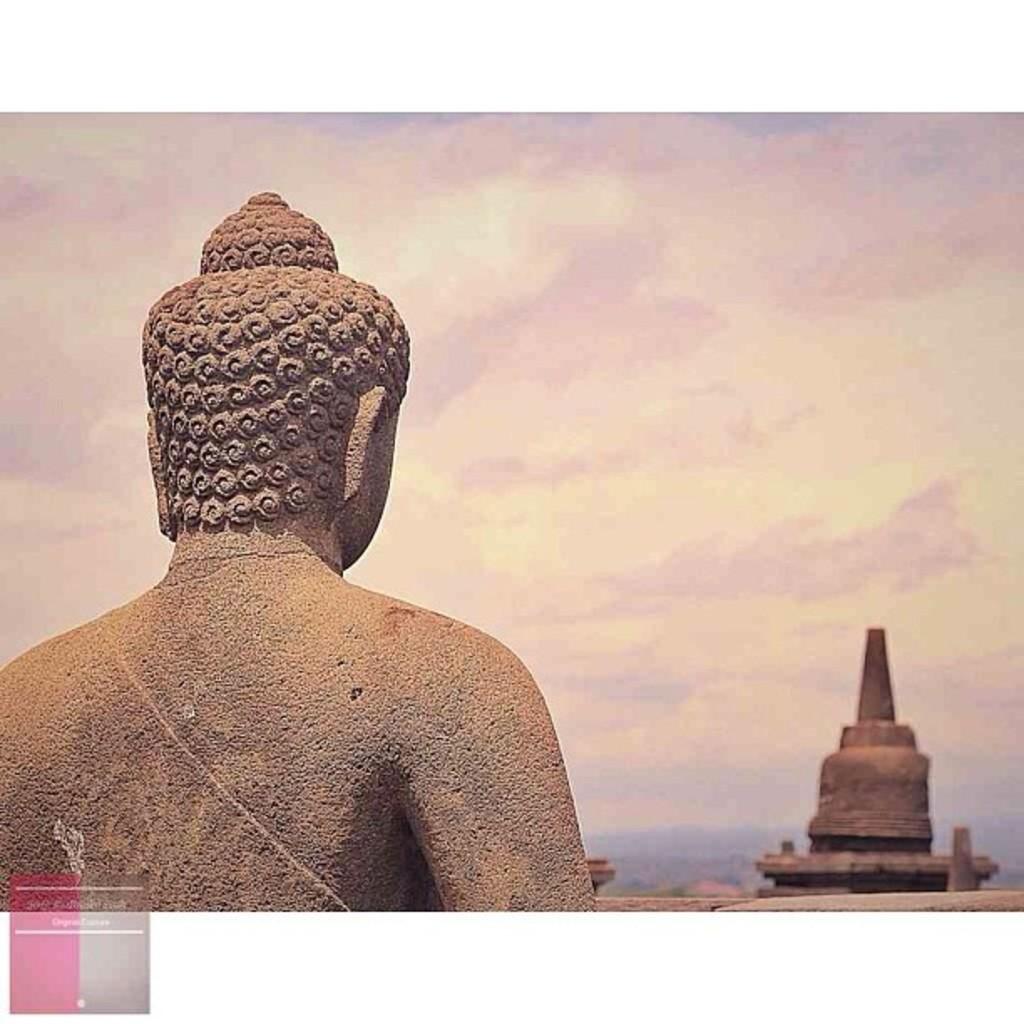What is the main subject in the image? There is a statue in the image. What can be seen in the background of the image? The sky is visible in the background of the image. What is located on the right side of the image? There is an object on the right side of the image. Where is the logo placed in the image? The logo is in the left side bottom corner of the image. What type of yarn is the statue holding in the image? The statue is not holding any yarn in the image. Can you tell me how many brothers are depicted in the image? There are no people, let alone brothers, depicted in the image; it features a statue. 